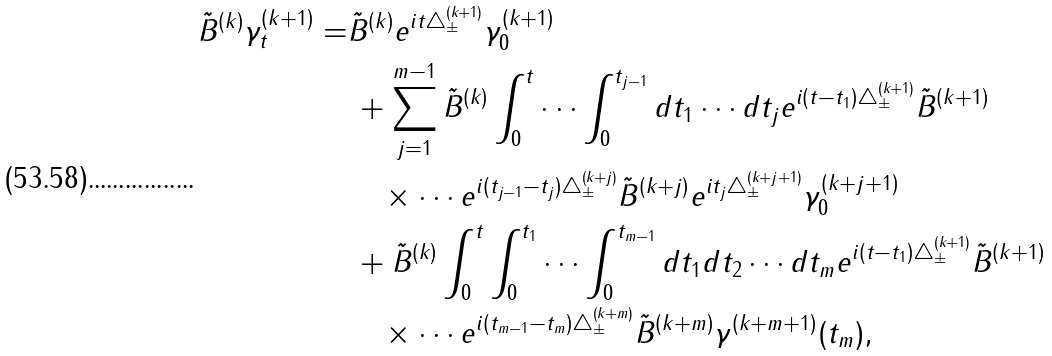<formula> <loc_0><loc_0><loc_500><loc_500>\tilde { B } ^ { ( k ) } \gamma ^ { ( k + 1 ) } _ { t } = & \tilde { B } ^ { ( k ) } e ^ { i t \triangle ^ { ( k + 1 ) } _ { \pm } } \gamma ^ { ( k + 1 ) } _ { 0 } \\ & \, + \sum ^ { m - 1 } _ { j = 1 } \tilde { B } ^ { ( k ) } \int ^ { t } _ { 0 } \cdots \int ^ { t _ { j - 1 } } _ { 0 } d t _ { 1 } \cdots d t _ { j } e ^ { i ( t - t _ { 1 } ) \triangle ^ { ( k + 1 ) } _ { \pm } } \tilde { B } ^ { ( k + 1 ) } \\ & \quad \times \cdots e ^ { i ( t _ { j - 1 } - t _ { j } ) \triangle ^ { ( k + j ) } _ { \pm } } \tilde { B } ^ { ( k + j ) } e ^ { i t _ { j } \triangle ^ { ( k + j + 1 ) } _ { \pm } } \gamma ^ { ( k + j + 1 ) } _ { 0 } \\ & \, + \tilde { B } ^ { ( k ) } \int ^ { t } _ { 0 } \int ^ { t _ { 1 } } _ { 0 } \cdots \int ^ { t _ { m - 1 } } _ { 0 } d t _ { 1 } d t _ { 2 } \cdots d t _ { m } e ^ { i ( t - t _ { 1 } ) \triangle ^ { ( k + 1 ) } _ { \pm } } \tilde { B } ^ { ( k + 1 ) } \\ & \quad \times \cdots e ^ { i ( t _ { m - 1 } - t _ { m } ) \triangle ^ { ( k + m ) } _ { \pm } } \tilde { B } ^ { ( k + m ) } \gamma ^ { ( k + m + 1 ) } ( t _ { m } ) ,</formula> 